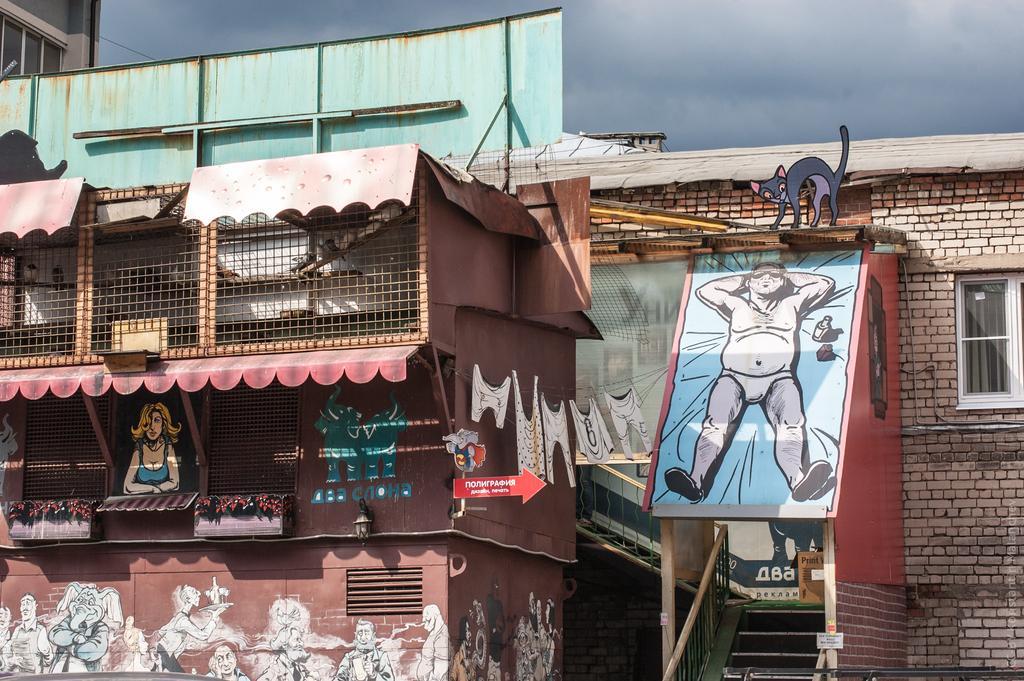Can you describe this image briefly? In this picture we can see few paintings on the wall, and we can find few metal rods, hoarding and few houses. 